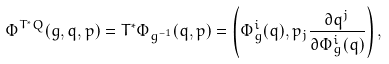Convert formula to latex. <formula><loc_0><loc_0><loc_500><loc_500>\Phi ^ { T ^ { * } Q } ( g , q , p ) = T ^ { * } \Phi _ { g ^ { - 1 } } ( q , p ) = \left ( \Phi _ { g } ^ { i } ( q ) , p _ { j } \frac { \partial q ^ { j } } { \partial \Phi _ { g } ^ { i } ( q ) } \right ) ,</formula> 